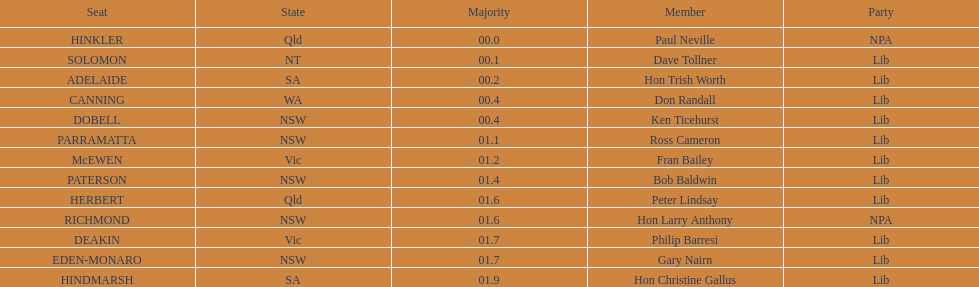Did fran bailey originate from victoria or western australia? Vic. 